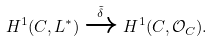<formula> <loc_0><loc_0><loc_500><loc_500>H ^ { 1 } ( C , L ^ { * } ) \xrightarrow { \tilde { \delta } } H ^ { 1 } ( C , \mathcal { O } _ { C } ) .</formula> 